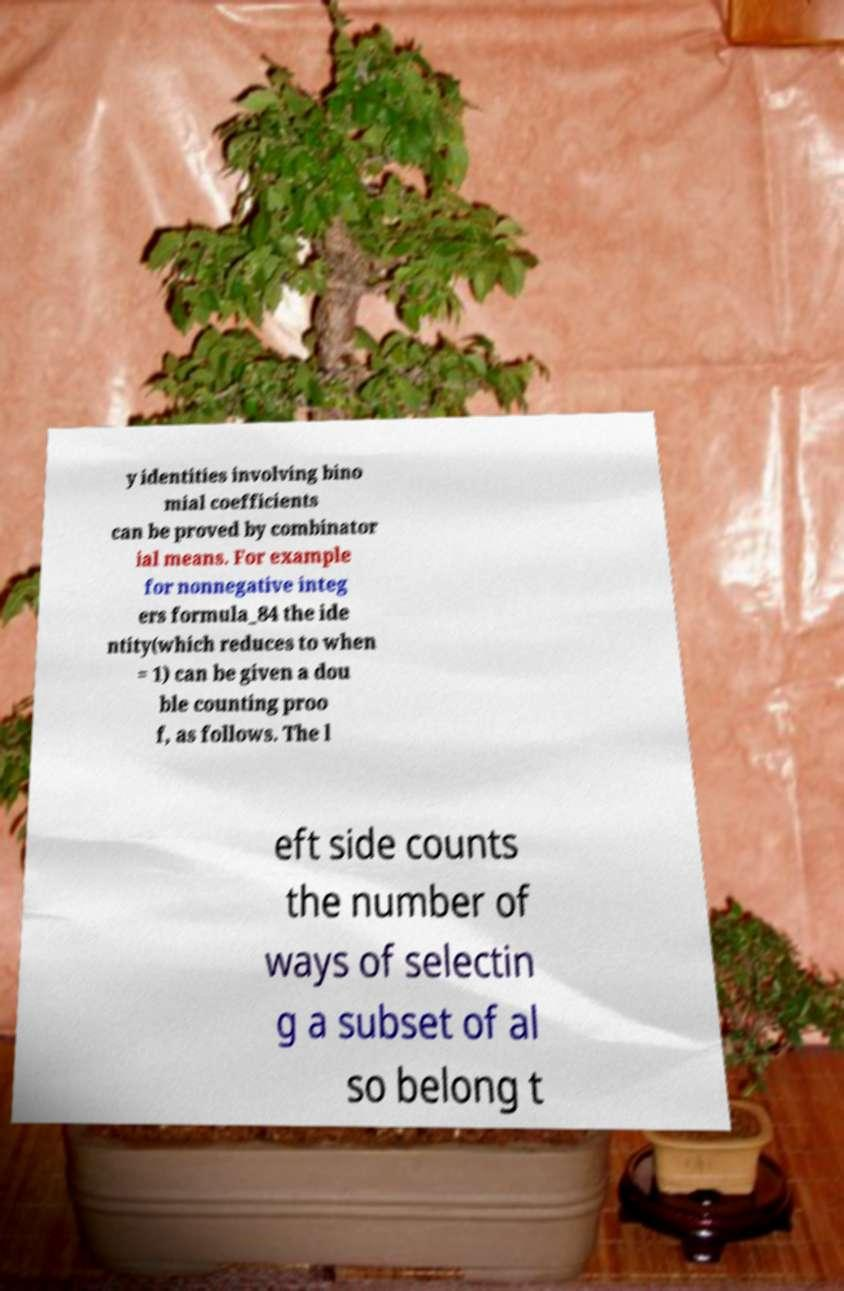Please read and relay the text visible in this image. What does it say? y identities involving bino mial coefficients can be proved by combinator ial means. For example for nonnegative integ ers formula_84 the ide ntity(which reduces to when = 1) can be given a dou ble counting proo f, as follows. The l eft side counts the number of ways of selectin g a subset of al so belong t 